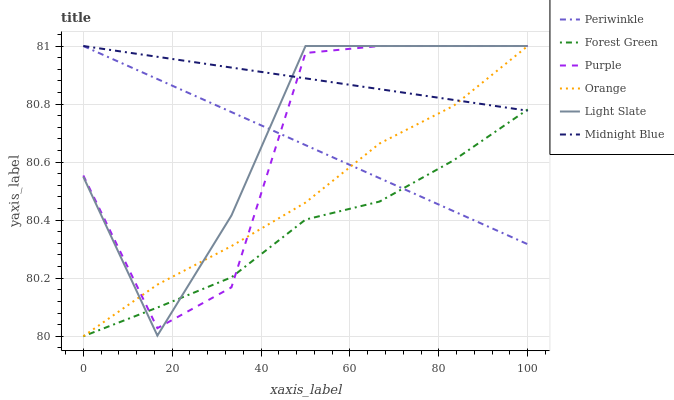Does Forest Green have the minimum area under the curve?
Answer yes or no. Yes. Does Midnight Blue have the maximum area under the curve?
Answer yes or no. Yes. Does Purple have the minimum area under the curve?
Answer yes or no. No. Does Purple have the maximum area under the curve?
Answer yes or no. No. Is Midnight Blue the smoothest?
Answer yes or no. Yes. Is Purple the roughest?
Answer yes or no. Yes. Is Light Slate the smoothest?
Answer yes or no. No. Is Light Slate the roughest?
Answer yes or no. No. Does Forest Green have the lowest value?
Answer yes or no. Yes. Does Purple have the lowest value?
Answer yes or no. No. Does Orange have the highest value?
Answer yes or no. Yes. Does Forest Green have the highest value?
Answer yes or no. No. Does Purple intersect Orange?
Answer yes or no. Yes. Is Purple less than Orange?
Answer yes or no. No. Is Purple greater than Orange?
Answer yes or no. No. 